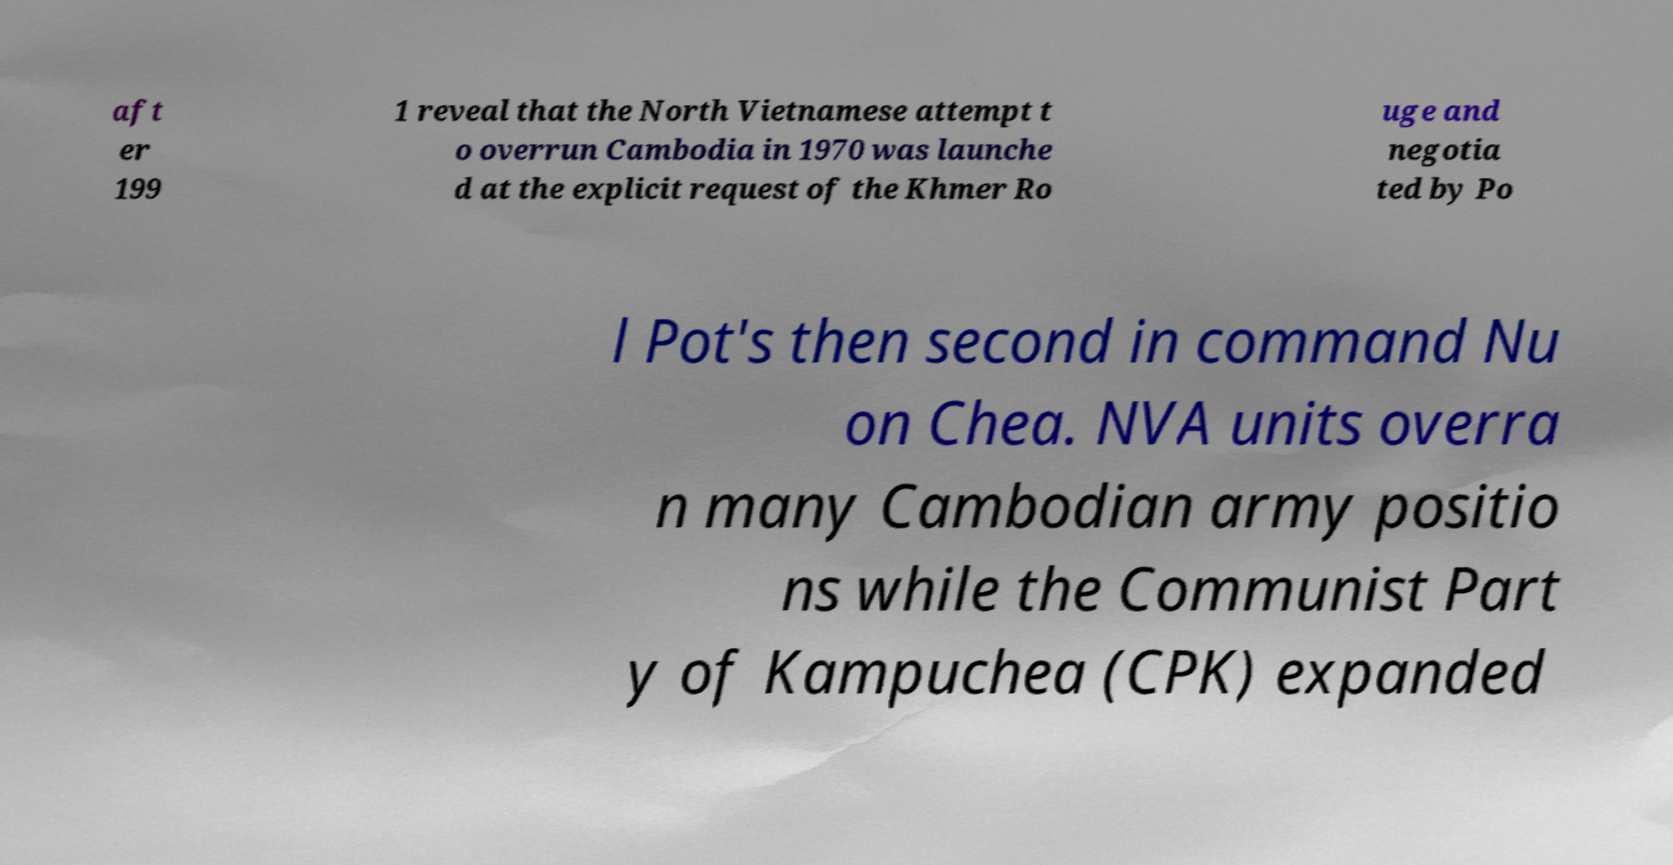What messages or text are displayed in this image? I need them in a readable, typed format. aft er 199 1 reveal that the North Vietnamese attempt t o overrun Cambodia in 1970 was launche d at the explicit request of the Khmer Ro uge and negotia ted by Po l Pot's then second in command Nu on Chea. NVA units overra n many Cambodian army positio ns while the Communist Part y of Kampuchea (CPK) expanded 